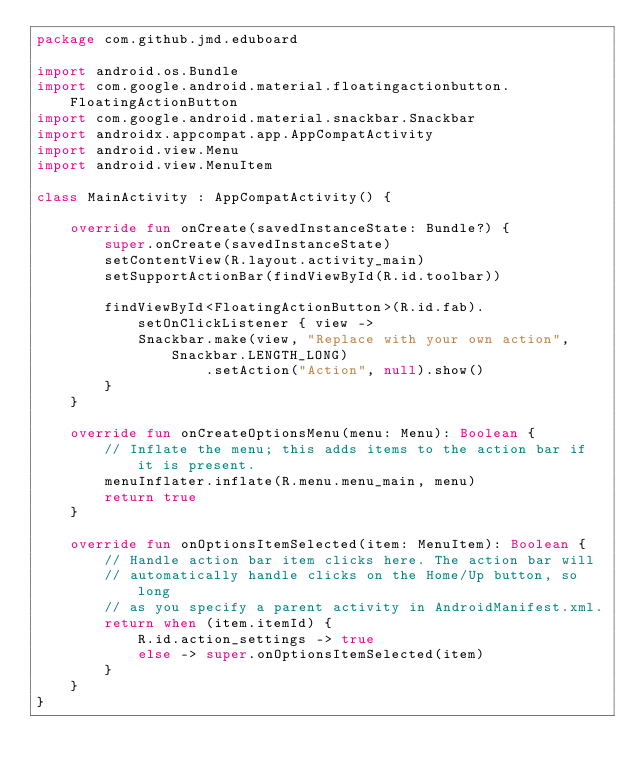<code> <loc_0><loc_0><loc_500><loc_500><_Kotlin_>package com.github.jmd.eduboard

import android.os.Bundle
import com.google.android.material.floatingactionbutton.FloatingActionButton
import com.google.android.material.snackbar.Snackbar
import androidx.appcompat.app.AppCompatActivity
import android.view.Menu
import android.view.MenuItem

class MainActivity : AppCompatActivity() {

    override fun onCreate(savedInstanceState: Bundle?) {
        super.onCreate(savedInstanceState)
        setContentView(R.layout.activity_main)
        setSupportActionBar(findViewById(R.id.toolbar))

        findViewById<FloatingActionButton>(R.id.fab).setOnClickListener { view ->
            Snackbar.make(view, "Replace with your own action", Snackbar.LENGTH_LONG)
                    .setAction("Action", null).show()
        }
    }

    override fun onCreateOptionsMenu(menu: Menu): Boolean {
        // Inflate the menu; this adds items to the action bar if it is present.
        menuInflater.inflate(R.menu.menu_main, menu)
        return true
    }

    override fun onOptionsItemSelected(item: MenuItem): Boolean {
        // Handle action bar item clicks here. The action bar will
        // automatically handle clicks on the Home/Up button, so long
        // as you specify a parent activity in AndroidManifest.xml.
        return when (item.itemId) {
            R.id.action_settings -> true
            else -> super.onOptionsItemSelected(item)
        }
    }
}</code> 